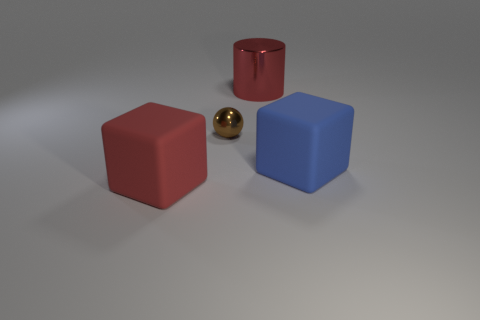Add 4 large red matte things. How many objects exist? 8 Subtract all cylinders. How many objects are left? 3 Subtract all big red rubber blocks. Subtract all brown metallic objects. How many objects are left? 2 Add 3 brown things. How many brown things are left? 4 Add 1 big red cylinders. How many big red cylinders exist? 2 Subtract 1 blue blocks. How many objects are left? 3 